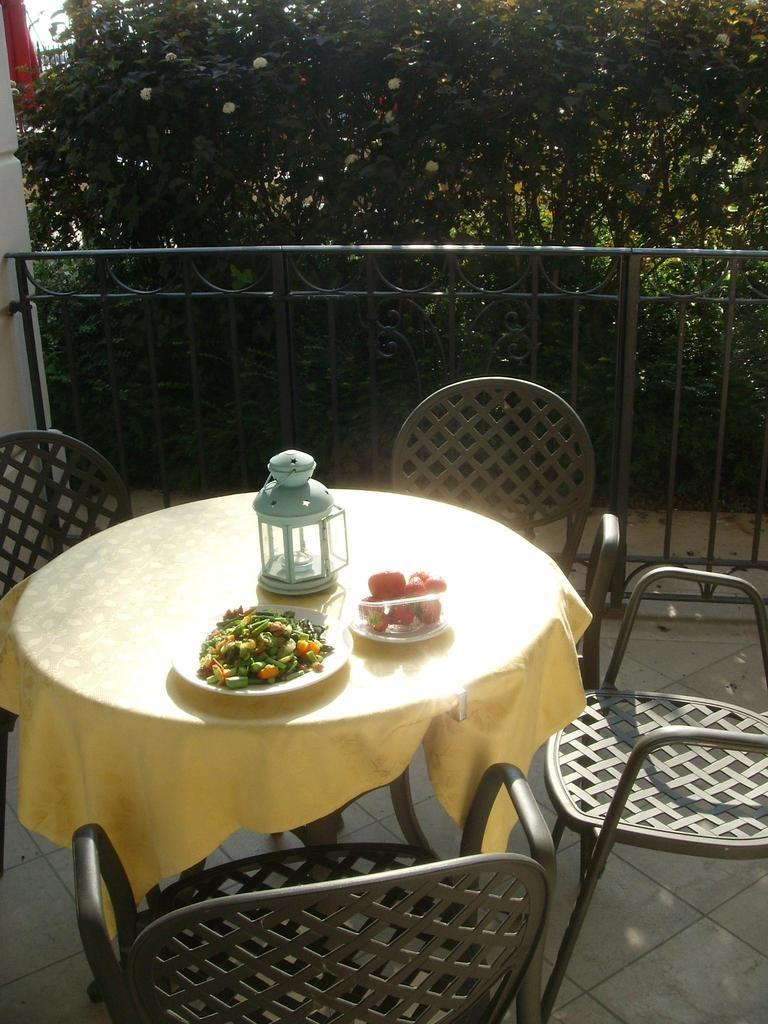What is located in the center of the image? There is a table in the center of the image. What can be found on the table? There are objects on the table. What type of furniture is present in the image? There are chairs in the image. What can be seen in the background of the image? There are trees in the background of the image. What type of architectural feature is present in the image? There is a fencing in the image. What type of lettuce is growing in the alley in the image? There is no alley or lettuce present in the image. What type of cemetery can be seen in the background of the image? There is no cemetery present in the image; it features trees in the background. 